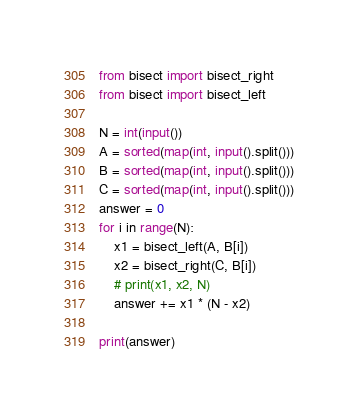<code> <loc_0><loc_0><loc_500><loc_500><_Python_>from bisect import bisect_right
from bisect import bisect_left

N = int(input())
A = sorted(map(int, input().split()))
B = sorted(map(int, input().split()))
C = sorted(map(int, input().split()))
answer = 0
for i in range(N):
    x1 = bisect_left(A, B[i])
    x2 = bisect_right(C, B[i])
    # print(x1, x2, N)
    answer += x1 * (N - x2)

print(answer)</code> 